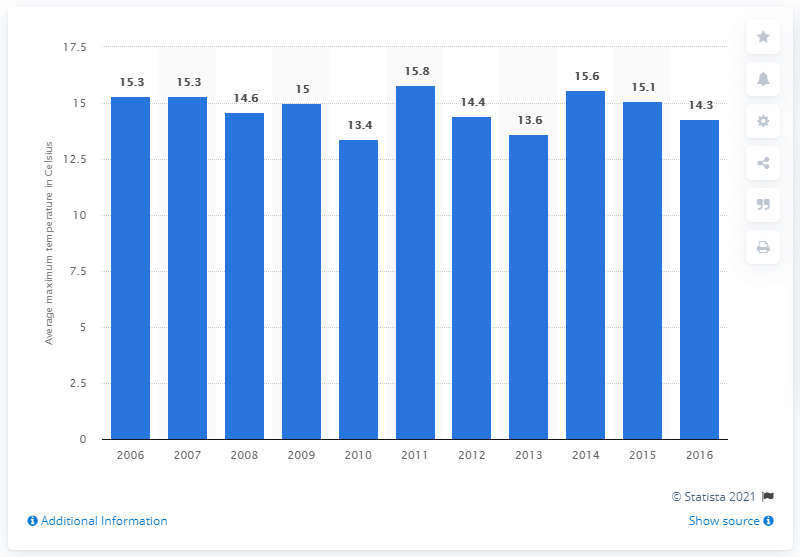Point out several critical features in this image. The highest average maximum temperature was recorded in Belgium in 2011. The lowest average temperature in Belgium was 13.4 degrees Celsius. 